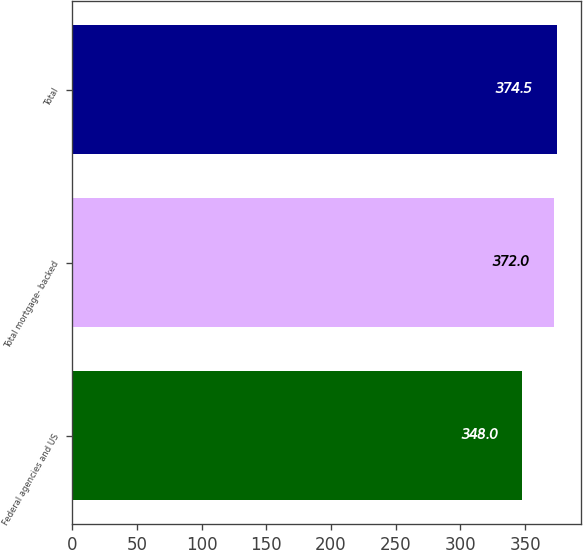Convert chart. <chart><loc_0><loc_0><loc_500><loc_500><bar_chart><fcel>Federal agencies and US<fcel>Total mortgage- backed<fcel>Total<nl><fcel>348<fcel>372<fcel>374.5<nl></chart> 